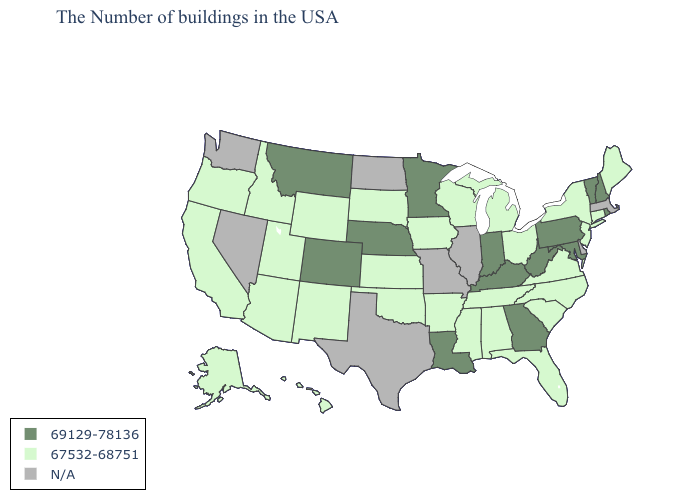Among the states that border Indiana , which have the lowest value?
Answer briefly. Ohio, Michigan. Which states hav the highest value in the West?
Write a very short answer. Colorado, Montana. What is the value of Georgia?
Give a very brief answer. 69129-78136. Name the states that have a value in the range 69129-78136?
Answer briefly. Rhode Island, New Hampshire, Vermont, Maryland, Pennsylvania, West Virginia, Georgia, Kentucky, Indiana, Louisiana, Minnesota, Nebraska, Colorado, Montana. Name the states that have a value in the range 69129-78136?
Write a very short answer. Rhode Island, New Hampshire, Vermont, Maryland, Pennsylvania, West Virginia, Georgia, Kentucky, Indiana, Louisiana, Minnesota, Nebraska, Colorado, Montana. What is the lowest value in the South?
Write a very short answer. 67532-68751. Name the states that have a value in the range 69129-78136?
Quick response, please. Rhode Island, New Hampshire, Vermont, Maryland, Pennsylvania, West Virginia, Georgia, Kentucky, Indiana, Louisiana, Minnesota, Nebraska, Colorado, Montana. What is the value of South Carolina?
Keep it brief. 67532-68751. What is the value of West Virginia?
Write a very short answer. 69129-78136. Is the legend a continuous bar?
Short answer required. No. Does the map have missing data?
Give a very brief answer. Yes. What is the value of South Carolina?
Answer briefly. 67532-68751. What is the value of Iowa?
Write a very short answer. 67532-68751. What is the highest value in the South ?
Answer briefly. 69129-78136. Among the states that border Montana , which have the lowest value?
Short answer required. South Dakota, Wyoming, Idaho. 